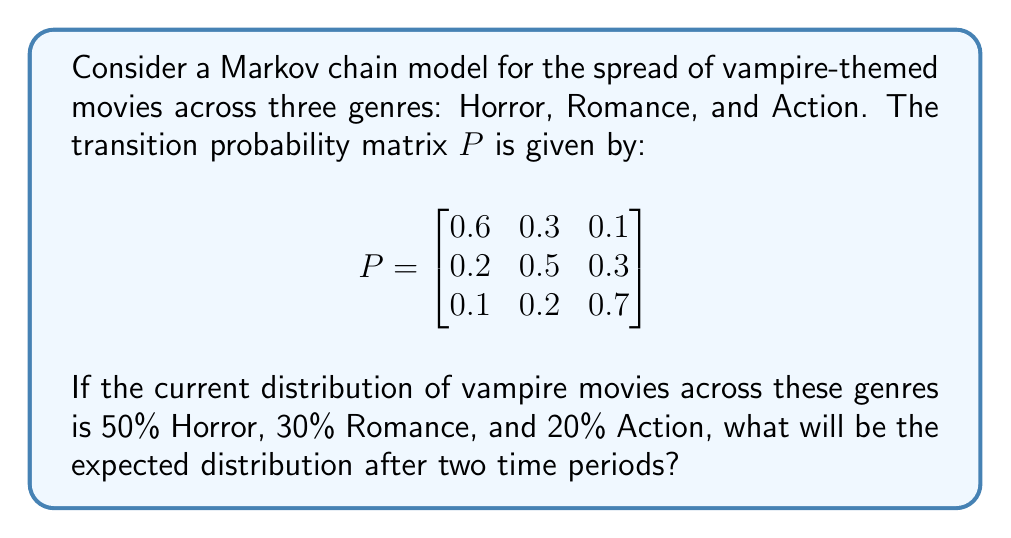Help me with this question. Let's approach this step-by-step:

1) First, we need to represent the initial distribution as a row vector:
   $$\pi_0 = [0.5 \quad 0.3 \quad 0.2]$$

2) To find the distribution after two time periods, we need to multiply this initial vector by the transition matrix P twice:
   $$\pi_2 = \pi_0 P^2$$

3) Let's calculate $P^2$ first:
   $$P^2 = P \times P = \begin{bmatrix}
   0.6 & 0.3 & 0.1 \\
   0.2 & 0.5 & 0.3 \\
   0.1 & 0.2 & 0.7
   \end{bmatrix} \times \begin{bmatrix}
   0.6 & 0.3 & 0.1 \\
   0.2 & 0.5 & 0.3 \\
   0.1 & 0.2 & 0.7
   \end{bmatrix}$$

4) Performing the matrix multiplication:
   $$P^2 = \begin{bmatrix}
   0.41 & 0.35 & 0.24 \\
   0.29 & 0.40 & 0.31 \\
   0.17 & 0.26 & 0.57
   \end{bmatrix}$$

5) Now, we multiply $\pi_0$ by $P^2$:
   $$\pi_2 = [0.5 \quad 0.3 \quad 0.2] \times \begin{bmatrix}
   0.41 & 0.35 & 0.24 \\
   0.29 & 0.40 & 0.31 \\
   0.17 & 0.26 & 0.57
   \end{bmatrix}$$

6) Performing this multiplication:
   $$\pi_2 = [0.3350 \quad 0.3530 \quad 0.3120]$$

7) Converting to percentages:
   Horror: 33.50%
   Romance: 35.30%
   Action: 31.20%
Answer: [33.50%, 35.30%, 31.20%] 